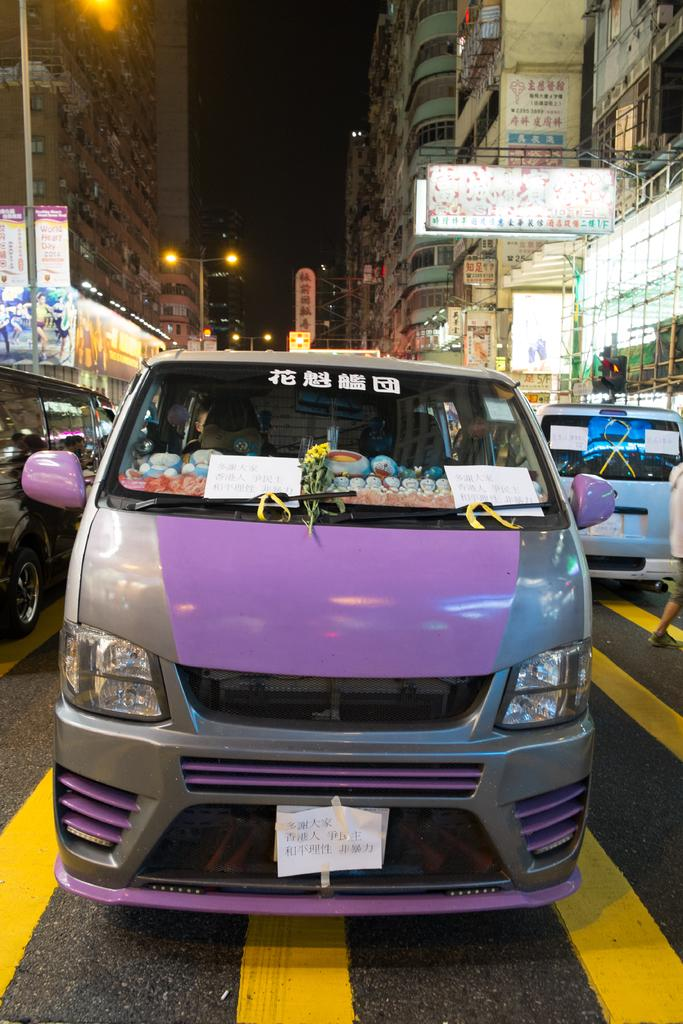What type of vehicle is on the road in the image? There is a van on the road in the image. What else can be seen on the road in the image? Vehicles are present on both sides of the image. What structures are visible in the image? Buildings are visible in the image. What additional features can be seen on the buildings? Banners and lights are present on the buildings. What type of sweater is being worn by the branch in the image? There is no sweater or branch present in the image. What type of play is being performed by the vehicles in the image? There is no play or performance involving the vehicles in the image; they are simply parked or driving on the road. 